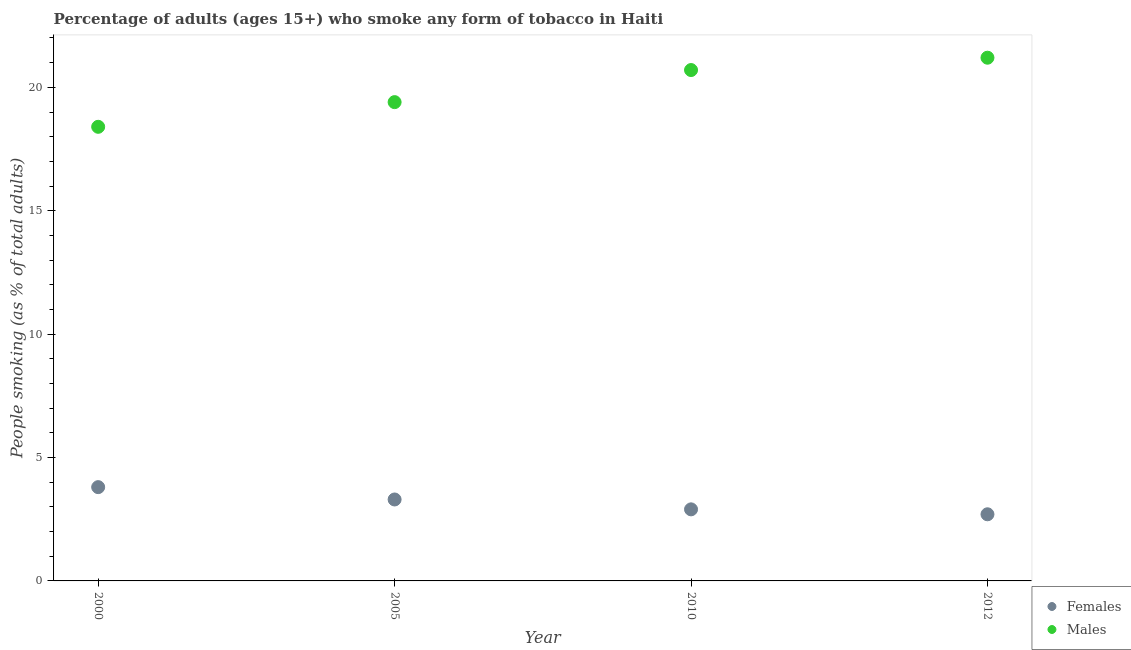Is the number of dotlines equal to the number of legend labels?
Provide a succinct answer. Yes. Across all years, what is the maximum percentage of males who smoke?
Offer a terse response. 21.2. In which year was the percentage of females who smoke maximum?
Offer a terse response. 2000. In which year was the percentage of females who smoke minimum?
Make the answer very short. 2012. What is the total percentage of males who smoke in the graph?
Make the answer very short. 79.7. What is the difference between the percentage of males who smoke in 2000 and that in 2010?
Offer a terse response. -2.3. What is the difference between the percentage of males who smoke in 2010 and the percentage of females who smoke in 2000?
Provide a succinct answer. 16.9. What is the average percentage of males who smoke per year?
Provide a succinct answer. 19.93. In the year 2005, what is the difference between the percentage of males who smoke and percentage of females who smoke?
Ensure brevity in your answer.  16.1. What is the ratio of the percentage of females who smoke in 2010 to that in 2012?
Ensure brevity in your answer.  1.07. Is the percentage of females who smoke in 2000 less than that in 2005?
Make the answer very short. No. Is the difference between the percentage of females who smoke in 2005 and 2012 greater than the difference between the percentage of males who smoke in 2005 and 2012?
Keep it short and to the point. Yes. What is the difference between the highest and the second highest percentage of females who smoke?
Provide a short and direct response. 0.5. What is the difference between the highest and the lowest percentage of females who smoke?
Keep it short and to the point. 1.1. Is the percentage of females who smoke strictly greater than the percentage of males who smoke over the years?
Your answer should be very brief. No. Is the percentage of females who smoke strictly less than the percentage of males who smoke over the years?
Your answer should be very brief. Yes. What is the difference between two consecutive major ticks on the Y-axis?
Provide a short and direct response. 5. Are the values on the major ticks of Y-axis written in scientific E-notation?
Offer a terse response. No. Does the graph contain grids?
Ensure brevity in your answer.  No. Where does the legend appear in the graph?
Offer a very short reply. Bottom right. How many legend labels are there?
Your answer should be compact. 2. What is the title of the graph?
Your response must be concise. Percentage of adults (ages 15+) who smoke any form of tobacco in Haiti. What is the label or title of the X-axis?
Your response must be concise. Year. What is the label or title of the Y-axis?
Provide a short and direct response. People smoking (as % of total adults). What is the People smoking (as % of total adults) in Females in 2000?
Your answer should be compact. 3.8. What is the People smoking (as % of total adults) of Males in 2005?
Offer a terse response. 19.4. What is the People smoking (as % of total adults) of Females in 2010?
Keep it short and to the point. 2.9. What is the People smoking (as % of total adults) in Males in 2010?
Provide a succinct answer. 20.7. What is the People smoking (as % of total adults) in Females in 2012?
Provide a succinct answer. 2.7. What is the People smoking (as % of total adults) of Males in 2012?
Offer a very short reply. 21.2. Across all years, what is the maximum People smoking (as % of total adults) in Females?
Provide a short and direct response. 3.8. Across all years, what is the maximum People smoking (as % of total adults) of Males?
Your answer should be very brief. 21.2. What is the total People smoking (as % of total adults) in Males in the graph?
Make the answer very short. 79.7. What is the difference between the People smoking (as % of total adults) of Males in 2000 and that in 2010?
Make the answer very short. -2.3. What is the difference between the People smoking (as % of total adults) in Females in 2005 and that in 2010?
Make the answer very short. 0.4. What is the difference between the People smoking (as % of total adults) of Males in 2005 and that in 2010?
Your answer should be compact. -1.3. What is the difference between the People smoking (as % of total adults) in Males in 2005 and that in 2012?
Offer a very short reply. -1.8. What is the difference between the People smoking (as % of total adults) in Females in 2010 and that in 2012?
Give a very brief answer. 0.2. What is the difference between the People smoking (as % of total adults) in Females in 2000 and the People smoking (as % of total adults) in Males in 2005?
Provide a succinct answer. -15.6. What is the difference between the People smoking (as % of total adults) of Females in 2000 and the People smoking (as % of total adults) of Males in 2010?
Give a very brief answer. -16.9. What is the difference between the People smoking (as % of total adults) of Females in 2000 and the People smoking (as % of total adults) of Males in 2012?
Offer a terse response. -17.4. What is the difference between the People smoking (as % of total adults) in Females in 2005 and the People smoking (as % of total adults) in Males in 2010?
Offer a very short reply. -17.4. What is the difference between the People smoking (as % of total adults) of Females in 2005 and the People smoking (as % of total adults) of Males in 2012?
Keep it short and to the point. -17.9. What is the difference between the People smoking (as % of total adults) in Females in 2010 and the People smoking (as % of total adults) in Males in 2012?
Make the answer very short. -18.3. What is the average People smoking (as % of total adults) in Females per year?
Give a very brief answer. 3.17. What is the average People smoking (as % of total adults) of Males per year?
Your response must be concise. 19.93. In the year 2000, what is the difference between the People smoking (as % of total adults) of Females and People smoking (as % of total adults) of Males?
Provide a short and direct response. -14.6. In the year 2005, what is the difference between the People smoking (as % of total adults) in Females and People smoking (as % of total adults) in Males?
Your answer should be very brief. -16.1. In the year 2010, what is the difference between the People smoking (as % of total adults) of Females and People smoking (as % of total adults) of Males?
Make the answer very short. -17.8. In the year 2012, what is the difference between the People smoking (as % of total adults) in Females and People smoking (as % of total adults) in Males?
Give a very brief answer. -18.5. What is the ratio of the People smoking (as % of total adults) in Females in 2000 to that in 2005?
Your answer should be very brief. 1.15. What is the ratio of the People smoking (as % of total adults) of Males in 2000 to that in 2005?
Give a very brief answer. 0.95. What is the ratio of the People smoking (as % of total adults) of Females in 2000 to that in 2010?
Your answer should be compact. 1.31. What is the ratio of the People smoking (as % of total adults) in Females in 2000 to that in 2012?
Your answer should be compact. 1.41. What is the ratio of the People smoking (as % of total adults) of Males in 2000 to that in 2012?
Make the answer very short. 0.87. What is the ratio of the People smoking (as % of total adults) of Females in 2005 to that in 2010?
Ensure brevity in your answer.  1.14. What is the ratio of the People smoking (as % of total adults) in Males in 2005 to that in 2010?
Ensure brevity in your answer.  0.94. What is the ratio of the People smoking (as % of total adults) in Females in 2005 to that in 2012?
Give a very brief answer. 1.22. What is the ratio of the People smoking (as % of total adults) in Males in 2005 to that in 2012?
Offer a very short reply. 0.92. What is the ratio of the People smoking (as % of total adults) of Females in 2010 to that in 2012?
Keep it short and to the point. 1.07. What is the ratio of the People smoking (as % of total adults) in Males in 2010 to that in 2012?
Your answer should be very brief. 0.98. What is the difference between the highest and the second highest People smoking (as % of total adults) in Males?
Your answer should be compact. 0.5. What is the difference between the highest and the lowest People smoking (as % of total adults) in Females?
Make the answer very short. 1.1. What is the difference between the highest and the lowest People smoking (as % of total adults) of Males?
Your answer should be very brief. 2.8. 